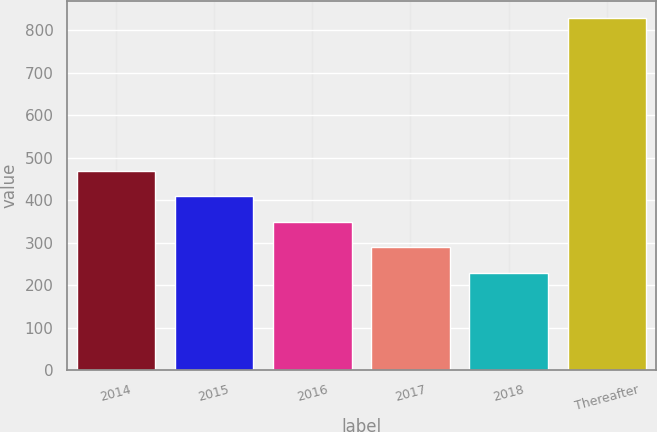<chart> <loc_0><loc_0><loc_500><loc_500><bar_chart><fcel>2014<fcel>2015<fcel>2016<fcel>2017<fcel>2018<fcel>Thereafter<nl><fcel>468.6<fcel>408.7<fcel>348.8<fcel>288.9<fcel>229<fcel>828<nl></chart> 